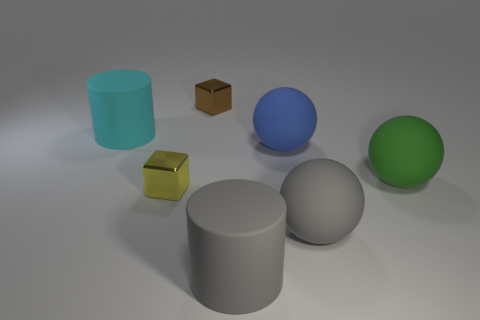Add 1 large gray things. How many objects exist? 8 Subtract all spheres. How many objects are left? 4 Add 5 yellow metal things. How many yellow metal things are left? 6 Add 2 green rubber balls. How many green rubber balls exist? 3 Subtract 1 gray cylinders. How many objects are left? 6 Subtract all large gray metal objects. Subtract all green rubber things. How many objects are left? 6 